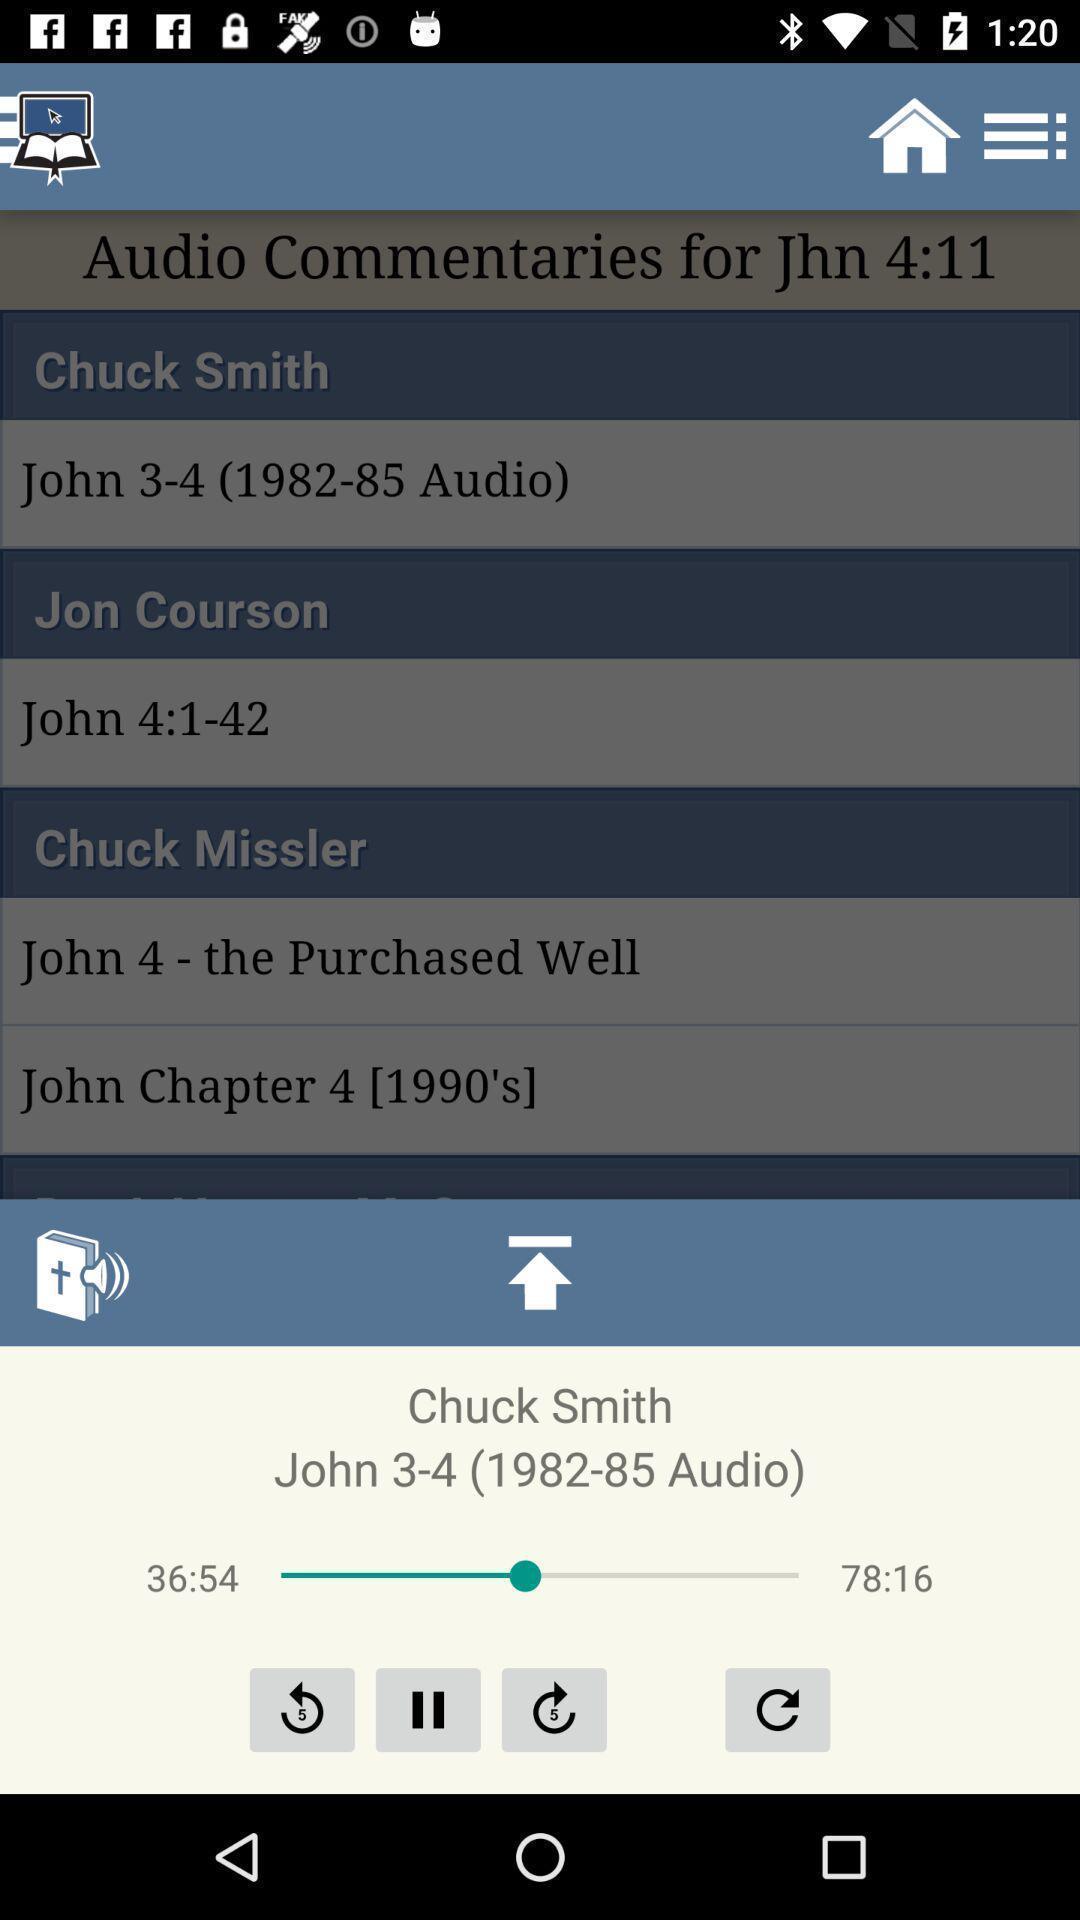Describe this image in words. Screen showing the music app page. 